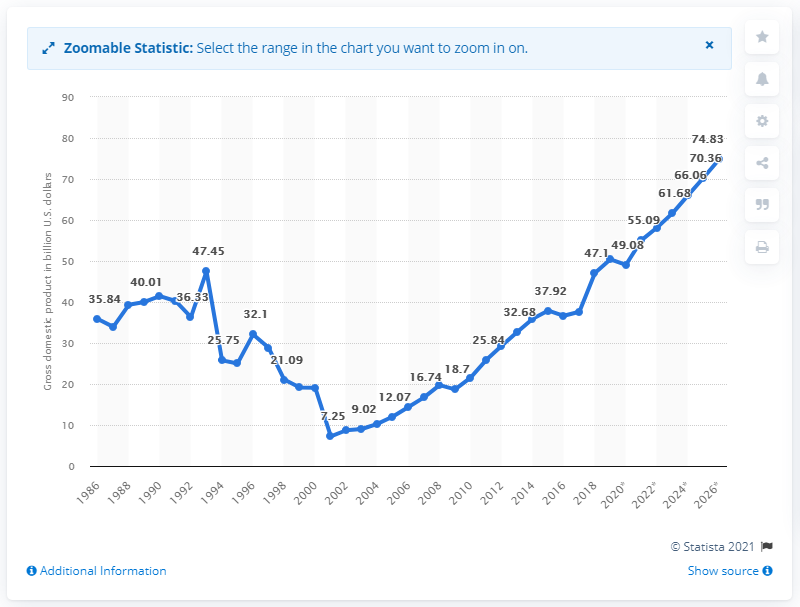Draw attention to some important aspects in this diagram. In 2019, the gross domestic product of the Democratic Republic of the Congo was 50.42 billion dollars. 